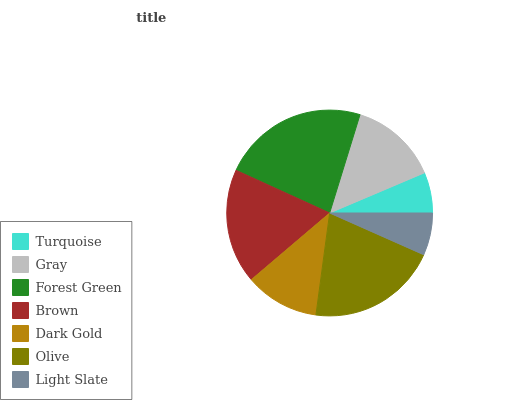Is Turquoise the minimum?
Answer yes or no. Yes. Is Forest Green the maximum?
Answer yes or no. Yes. Is Gray the minimum?
Answer yes or no. No. Is Gray the maximum?
Answer yes or no. No. Is Gray greater than Turquoise?
Answer yes or no. Yes. Is Turquoise less than Gray?
Answer yes or no. Yes. Is Turquoise greater than Gray?
Answer yes or no. No. Is Gray less than Turquoise?
Answer yes or no. No. Is Gray the high median?
Answer yes or no. Yes. Is Gray the low median?
Answer yes or no. Yes. Is Light Slate the high median?
Answer yes or no. No. Is Brown the low median?
Answer yes or no. No. 